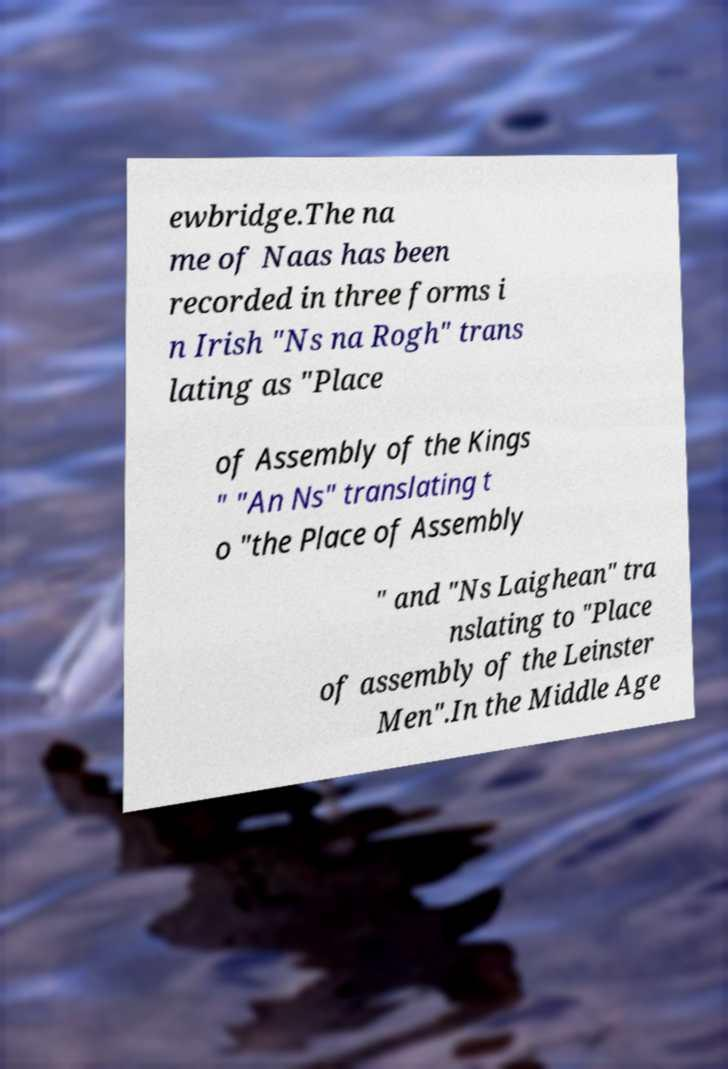Please identify and transcribe the text found in this image. ewbridge.The na me of Naas has been recorded in three forms i n Irish "Ns na Rogh" trans lating as "Place of Assembly of the Kings " "An Ns" translating t o "the Place of Assembly " and "Ns Laighean" tra nslating to "Place of assembly of the Leinster Men".In the Middle Age 